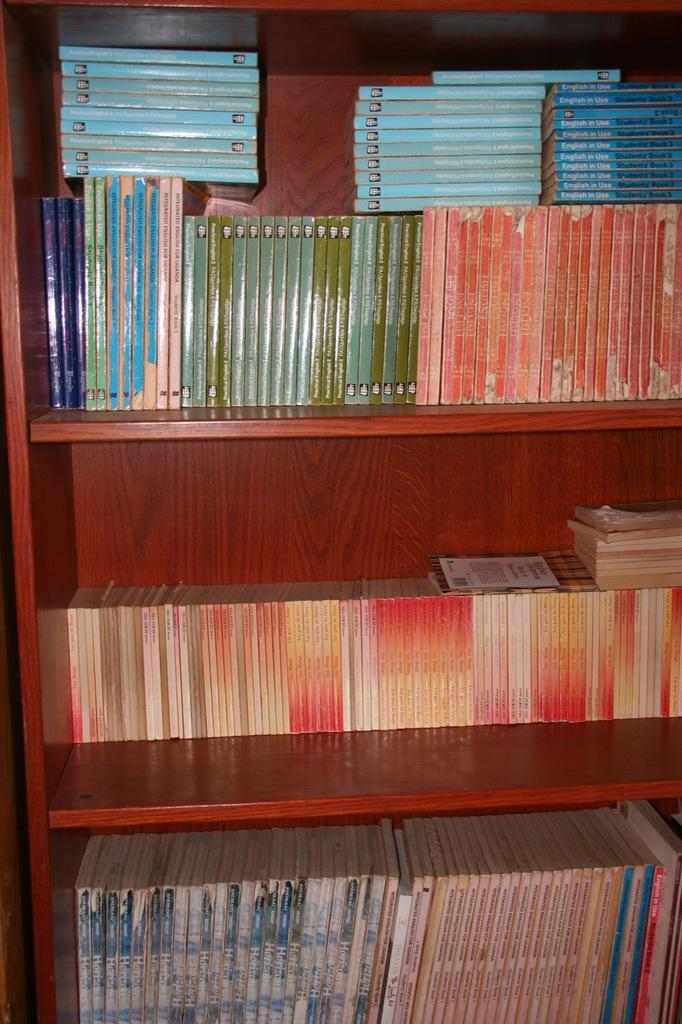What type of furniture is present in the image? There is a bookshelf in the image. What colors are used for the bookshelf? The bookshelf is brown and orange in color. What items can be found on the bookshelf? There are books on the bookshelf. What colors can be seen on the books? The books have various colors, including blue, orange, green, red, and cream. Can you hear the bells ringing in the image? There are no bells present in the image, so it is not possible to hear them ringing. 